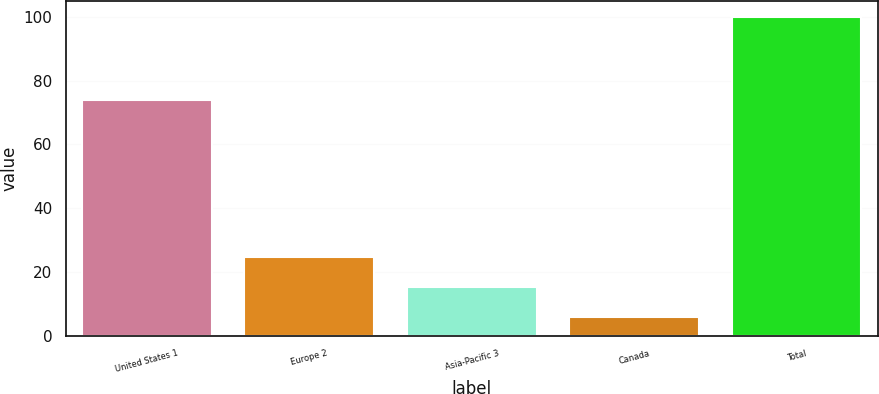Convert chart. <chart><loc_0><loc_0><loc_500><loc_500><bar_chart><fcel>United States 1<fcel>Europe 2<fcel>Asia-Pacific 3<fcel>Canada<fcel>Total<nl><fcel>74<fcel>24.8<fcel>15.4<fcel>6<fcel>100<nl></chart> 